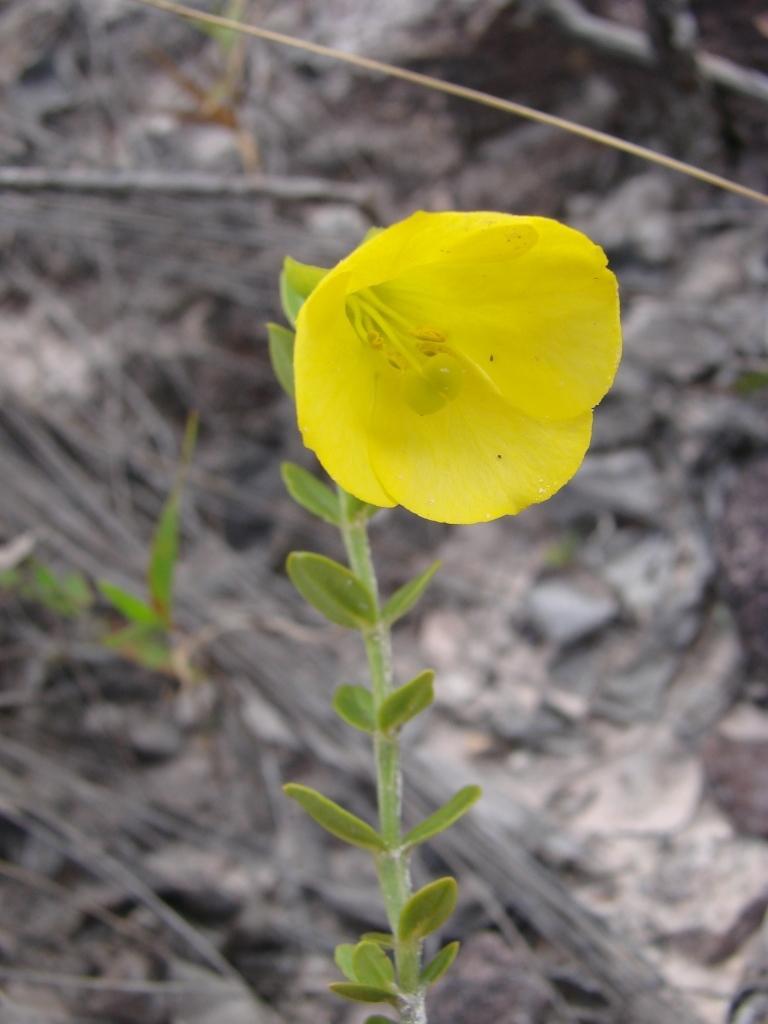Can you describe this image briefly? In this picture there is a flower to a plant and it is in yellow in color and the background is in black and white. 